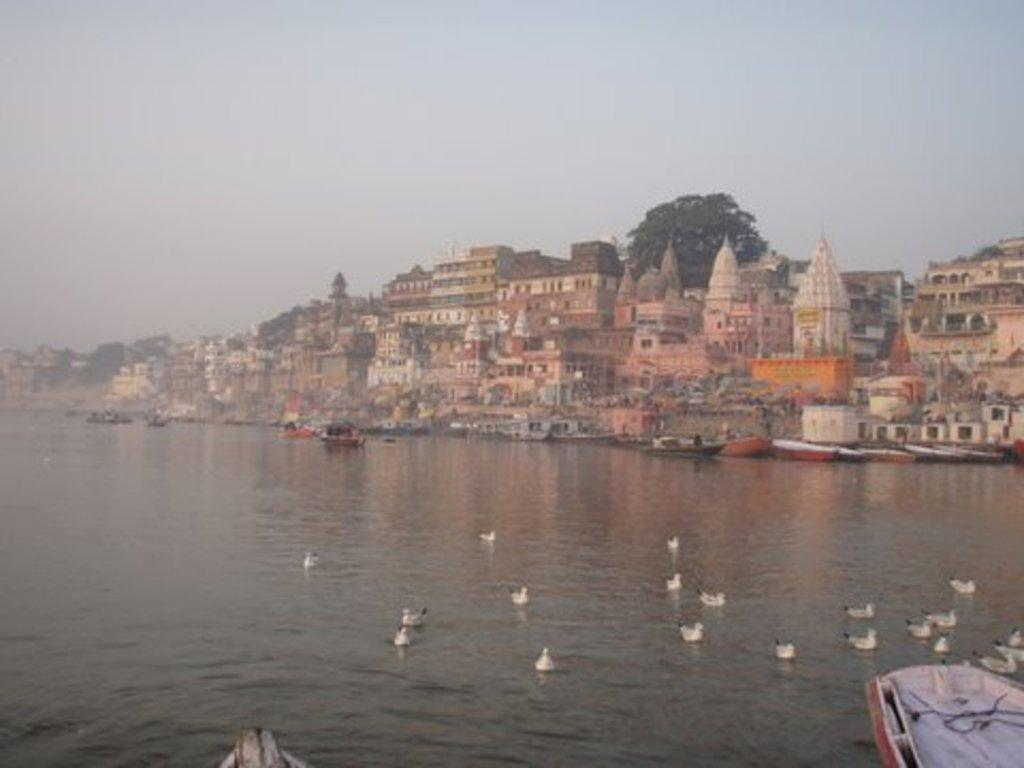What is the main element in the image? There is water in the image. What can be seen in the water? There are small ducks in the water. What is located to the right of the image? There is a boat to the right of the image. What can be seen in the background of the image? There are temples and buildings in the background of the image. What type of fan is visible in the image? There is no fan present in the image. What is the shape of the heart in the image? There is no heart present in the image. 